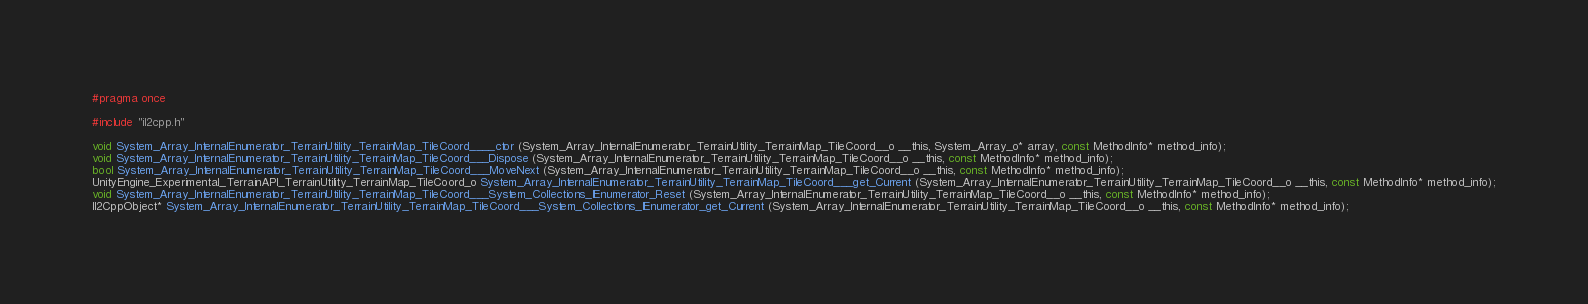<code> <loc_0><loc_0><loc_500><loc_500><_C_>#pragma once

#include "il2cpp.h"

void System_Array_InternalEnumerator_TerrainUtility_TerrainMap_TileCoord____ctor (System_Array_InternalEnumerator_TerrainUtility_TerrainMap_TileCoord__o __this, System_Array_o* array, const MethodInfo* method_info);
void System_Array_InternalEnumerator_TerrainUtility_TerrainMap_TileCoord___Dispose (System_Array_InternalEnumerator_TerrainUtility_TerrainMap_TileCoord__o __this, const MethodInfo* method_info);
bool System_Array_InternalEnumerator_TerrainUtility_TerrainMap_TileCoord___MoveNext (System_Array_InternalEnumerator_TerrainUtility_TerrainMap_TileCoord__o __this, const MethodInfo* method_info);
UnityEngine_Experimental_TerrainAPI_TerrainUtility_TerrainMap_TileCoord_o System_Array_InternalEnumerator_TerrainUtility_TerrainMap_TileCoord___get_Current (System_Array_InternalEnumerator_TerrainUtility_TerrainMap_TileCoord__o __this, const MethodInfo* method_info);
void System_Array_InternalEnumerator_TerrainUtility_TerrainMap_TileCoord___System_Collections_IEnumerator_Reset (System_Array_InternalEnumerator_TerrainUtility_TerrainMap_TileCoord__o __this, const MethodInfo* method_info);
Il2CppObject* System_Array_InternalEnumerator_TerrainUtility_TerrainMap_TileCoord___System_Collections_IEnumerator_get_Current (System_Array_InternalEnumerator_TerrainUtility_TerrainMap_TileCoord__o __this, const MethodInfo* method_info);
</code> 